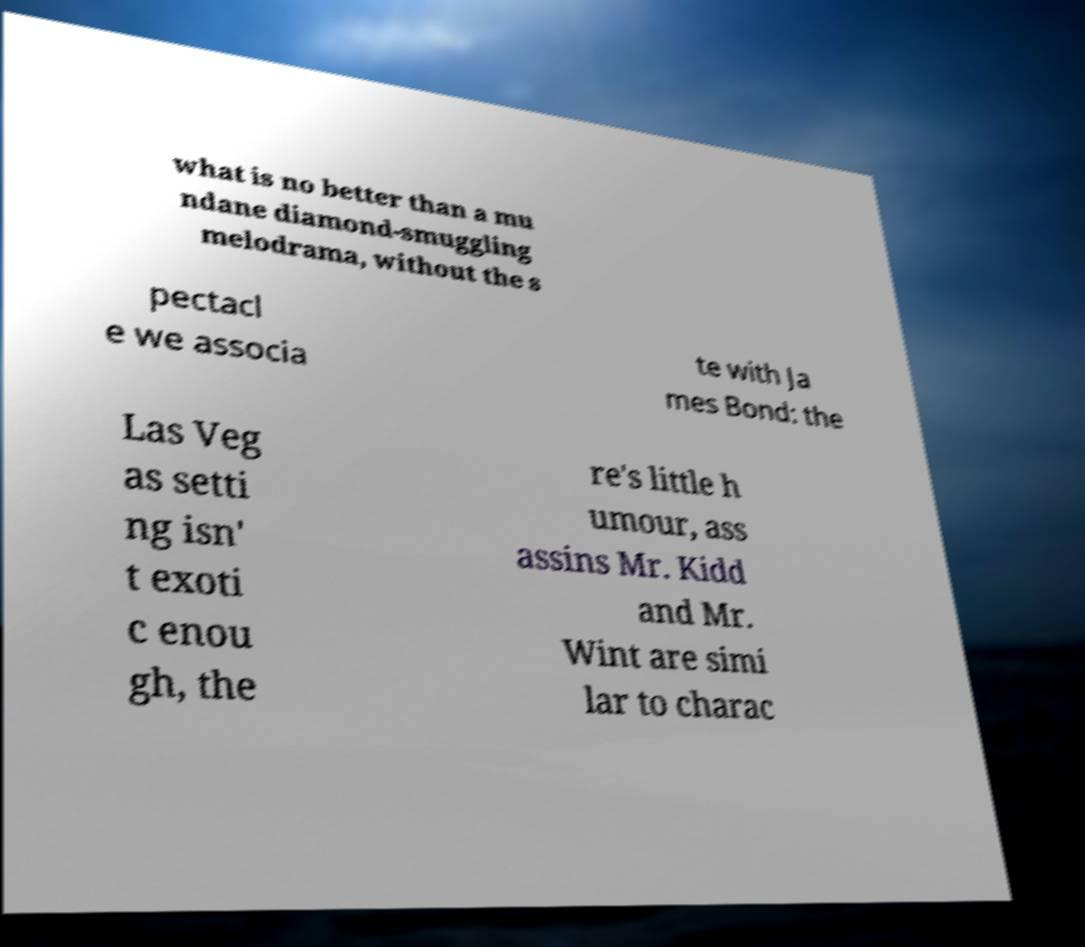What messages or text are displayed in this image? I need them in a readable, typed format. what is no better than a mu ndane diamond-smuggling melodrama, without the s pectacl e we associa te with Ja mes Bond: the Las Veg as setti ng isn' t exoti c enou gh, the re's little h umour, ass assins Mr. Kidd and Mr. Wint are simi lar to charac 